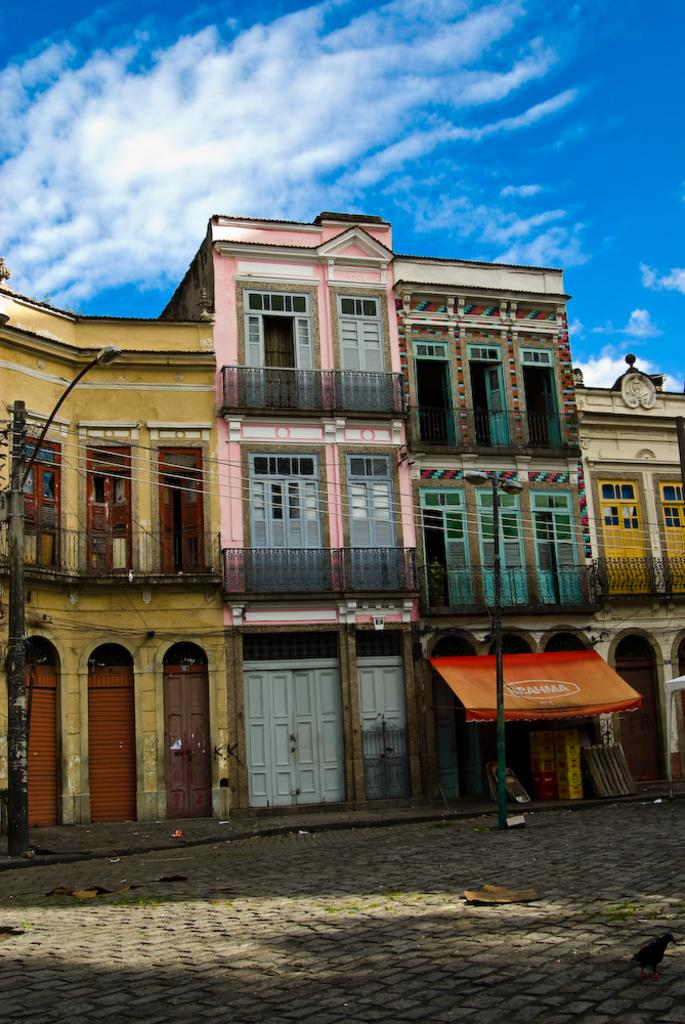What type of animal can be seen on the surface in the image? There is a bird on the surface in the image. What structures are present in the image? There are poles, lights, wires, a building, doors, and railings in the image. What is the background of the image? The sky is visible in the background of the image, with clouds present. What month is it in the image? The month cannot be determined from the image, as there is no information about the time of year. Can you see any gloves in the image? There are no gloves present in the image. 